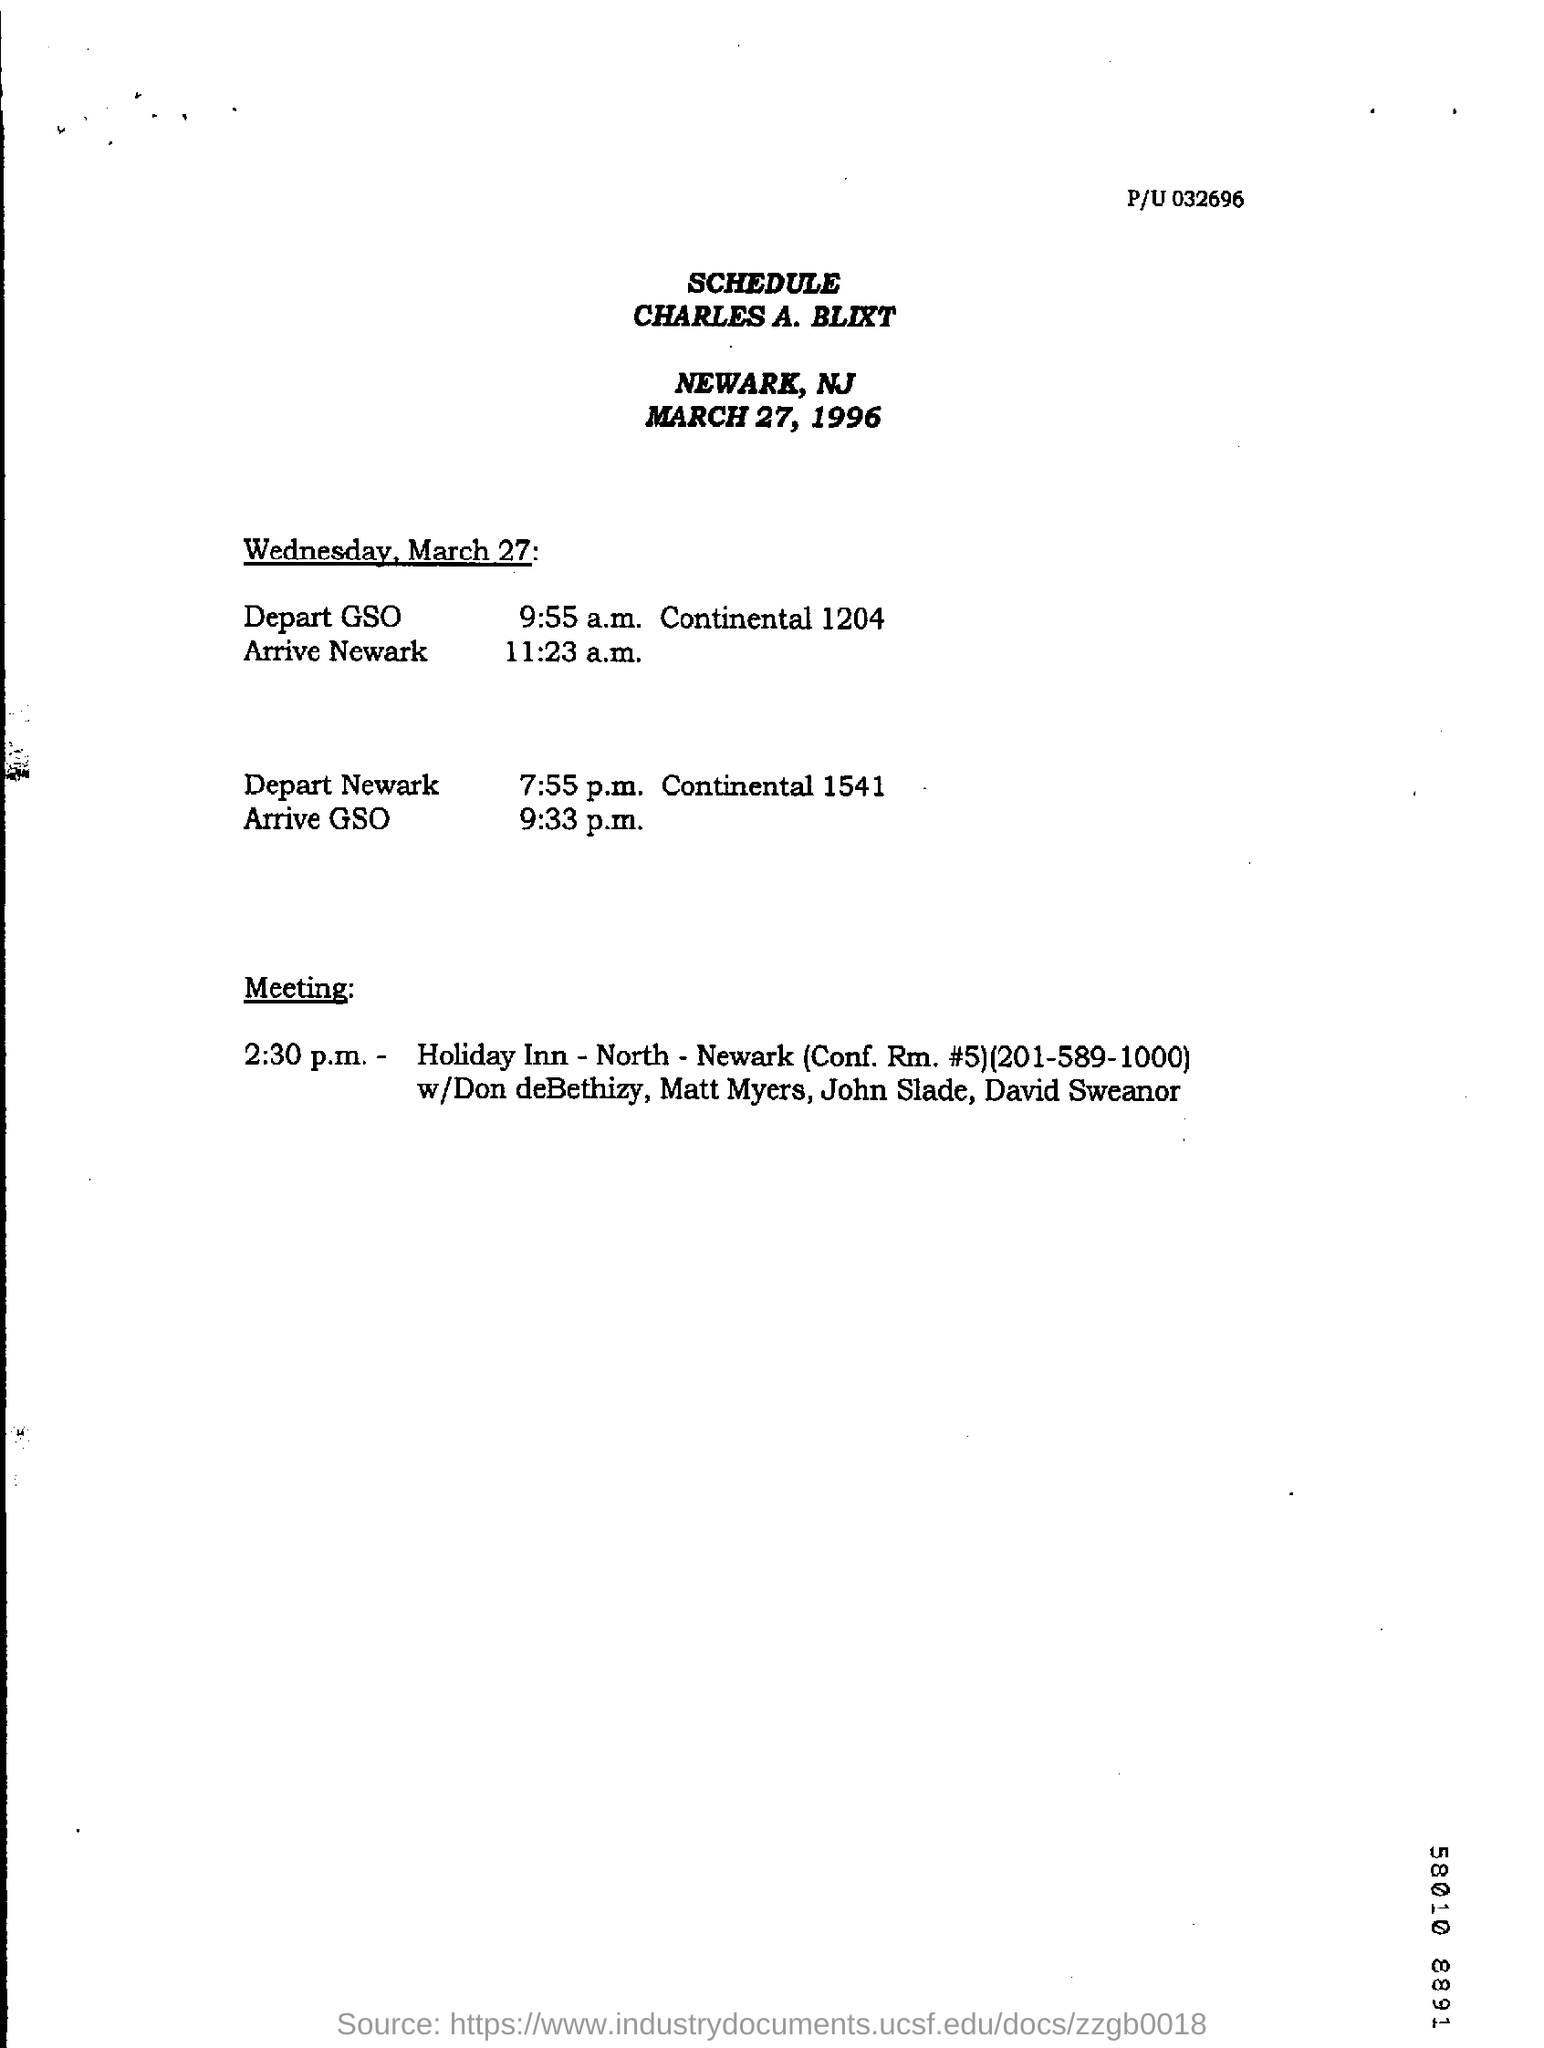Highlight a few significant elements in this photo. The arrival time in GSO is 9:33 p.m. The departure time of GSO is 9:55 a.m. 